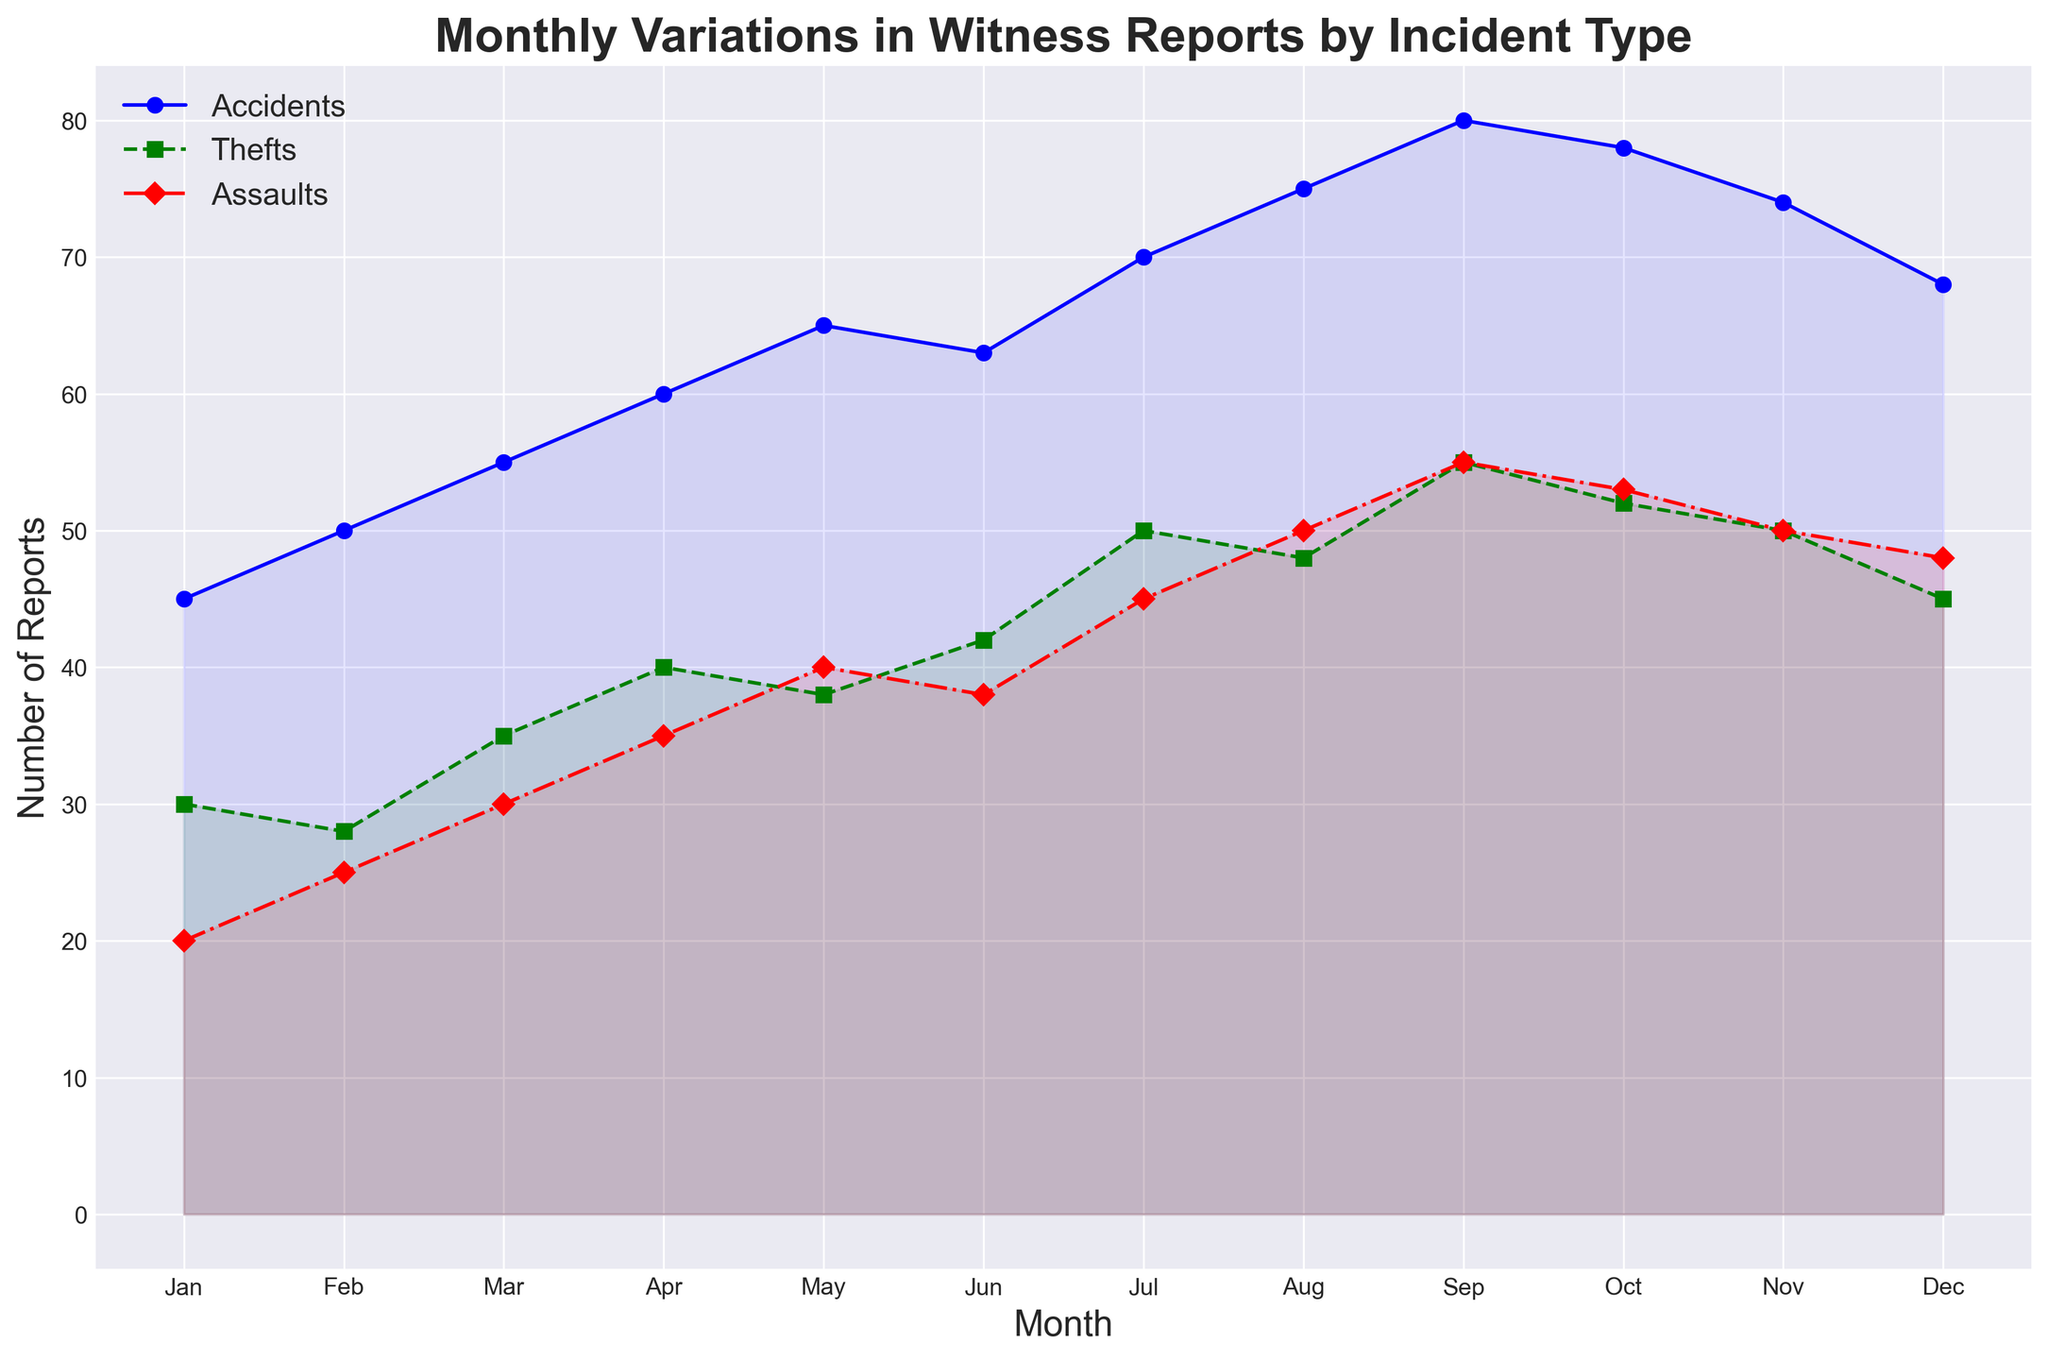Which incident type had the highest number of reports in July? In the chart, find the data points for July and compare the values of accidents, thefts, and assaults. The highest value among them is for accidents.
Answer: Accidents How many more reports were there for accidents in September compared to February? Refer to the values for accidents in September and February, which are 80 and 50 respectively. The difference is 80 - 50 = 30.
Answer: 30 What is the total number of witness reports for assaults across the entire year? Sum the monthly values for assaults. The sum is 20 + 25 + 30 + 35 + 40 + 38 + 45 + 50 + 55 + 53 + 50 + 48 = 489.
Answer: 489 Which month saw the highest number of thefts? Look at the line for thefts (green) and check the month where the highest value occurs. The highest thefts are in September.
Answer: September What is the average number of reports for accidents in the first quarter (Jan-Mar)? Add the values for accidents in January, February, and March, then divide by 3. These values are 45, 50, 55. The sum is 45 + 50 + 55 = 150. The average is 150 / 3 = 50.
Answer: 50 In which month did assaults surpass 40 reports for the first time? Trace the line for assaults (red) and check where it first crosses the 40 reports mark. Assaults surpass 40 reports in May.
Answer: May Compare the total number of reports for accidents and thefts in June. Which had more and by how much? Add the values for accidents and thefts in June. Accidents: 63, Thefts: 42. Compare them by subtracting the smaller number from the larger one, 63 - 42 = 21. Accidents had 21 more reports.
Answer: Accidents had 21 more What was the trend for thefts from January to December? Observe the line for thefts (green) from left to right. Thefts generally increased over the year, peaking around September and then decreasing towards December.
Answer: Increased, then decreased Which incident type had the most significant increase from January to December? Compare the starting and ending points of each line. The increase from January to December for accidents is (68-45)=23, thefts is (45-30)=15, assaults is (48-20)=28. The most significant increase is in assaults.
Answer: Assaults During which month were witness reports for accidents at their peak, and what was the value? Find the peak point for the line representing accidents (blue). The highest value occurs in September, with 80 reports.
Answer: September, 80 